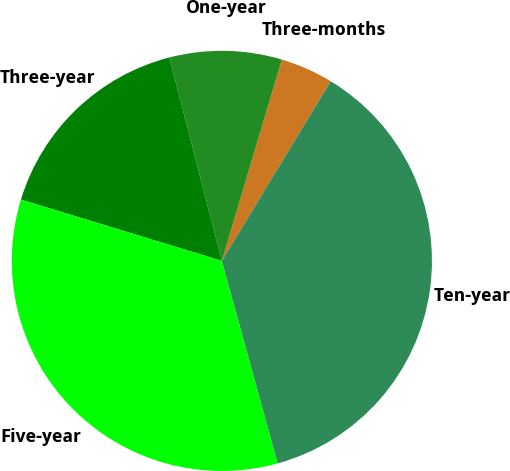Convert chart to OTSL. <chart><loc_0><loc_0><loc_500><loc_500><pie_chart><fcel>Three-months<fcel>One-year<fcel>Three-year<fcel>Five-year<fcel>Ten-year<nl><fcel>4.06%<fcel>8.63%<fcel>16.27%<fcel>33.99%<fcel>37.05%<nl></chart> 